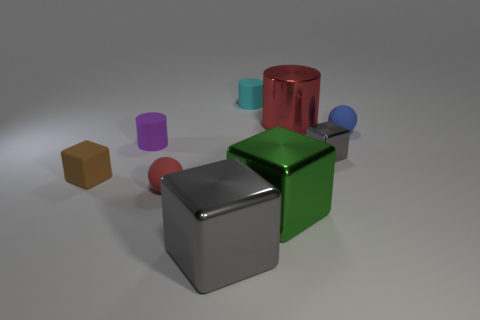What is the shape of the object that is in front of the brown object and left of the big gray thing?
Provide a succinct answer. Sphere. Are there more big red metal cylinders that are behind the small gray object than cyan matte balls?
Your response must be concise. Yes. The red cylinder that is the same material as the big gray object is what size?
Offer a terse response. Large. What number of tiny things have the same color as the large metal cylinder?
Give a very brief answer. 1. There is a sphere left of the green thing; is its color the same as the tiny shiny block?
Give a very brief answer. No. Is the number of spheres that are to the left of the blue ball the same as the number of cylinders that are to the left of the big cylinder?
Your answer should be compact. No. There is a tiny ball that is to the right of the small red thing; what is its color?
Give a very brief answer. Blue. Are there the same number of red objects that are in front of the big gray shiny cube and cyan metal cylinders?
Offer a very short reply. Yes. How many other objects are the same shape as the brown object?
Give a very brief answer. 3. There is a small purple rubber thing; what number of small cyan matte cylinders are behind it?
Your answer should be compact. 1. 